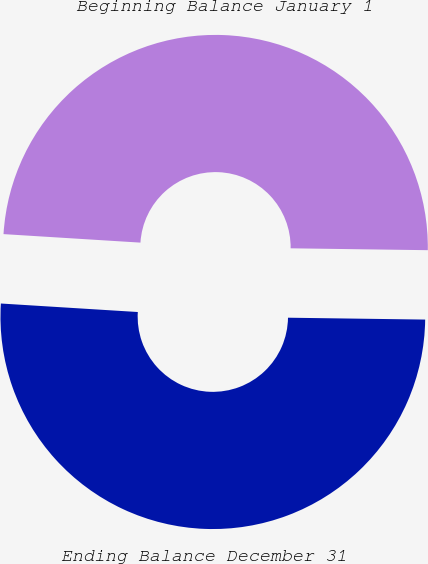Convert chart to OTSL. <chart><loc_0><loc_0><loc_500><loc_500><pie_chart><fcel>Beginning Balance January 1<fcel>Ending Balance December 31<nl><fcel>49.23%<fcel>50.77%<nl></chart> 